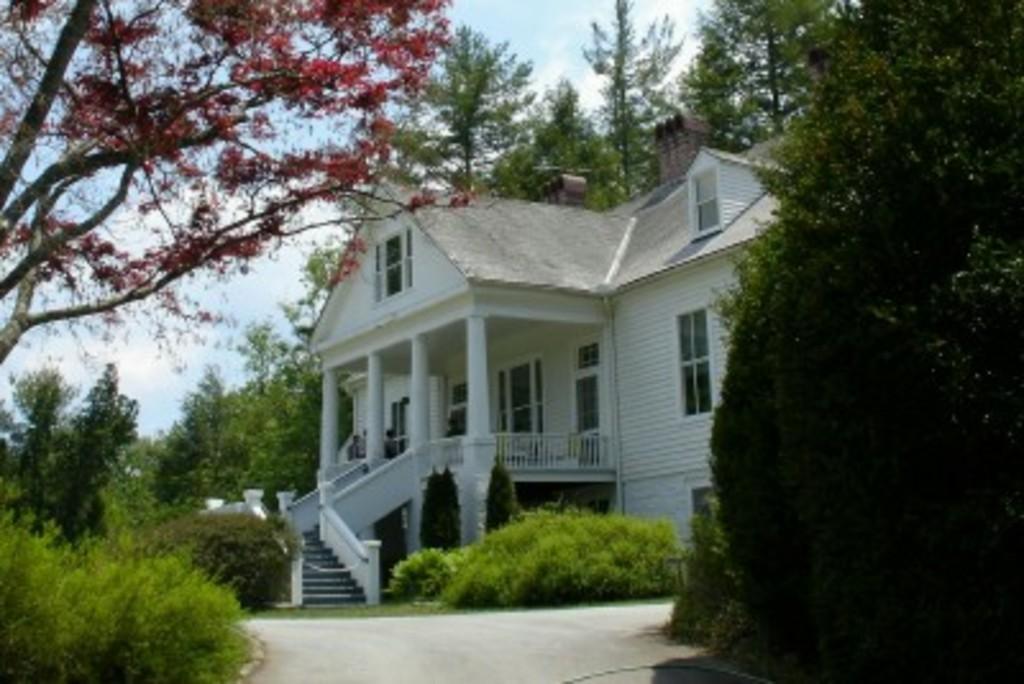In one or two sentences, can you explain what this image depicts? In this image there is a building. There is a railing to the building. In front of the building there are steps. Around the building there are trees, plants and hedges. At the bottom there is a path. At the top there is the sky. 